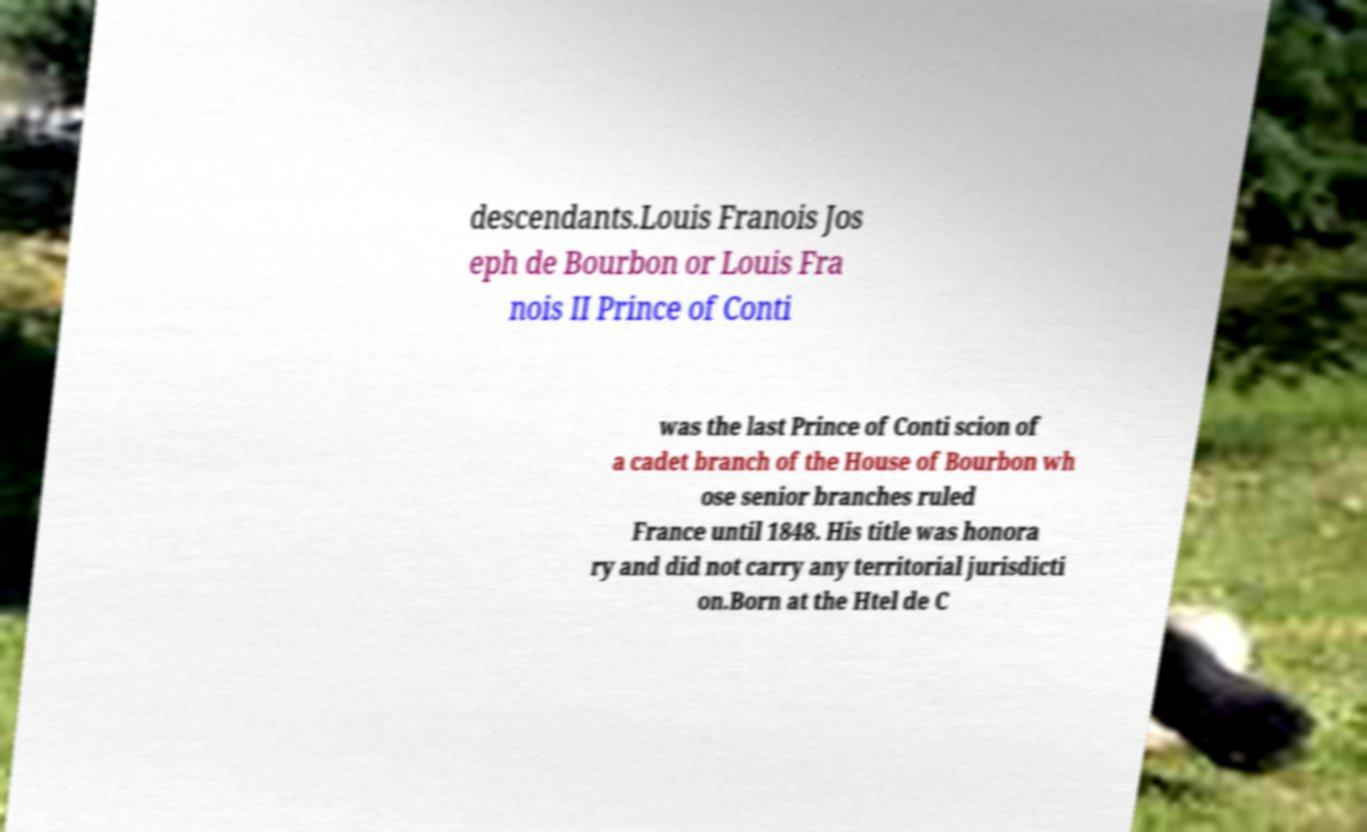Can you accurately transcribe the text from the provided image for me? descendants.Louis Franois Jos eph de Bourbon or Louis Fra nois II Prince of Conti was the last Prince of Conti scion of a cadet branch of the House of Bourbon wh ose senior branches ruled France until 1848. His title was honora ry and did not carry any territorial jurisdicti on.Born at the Htel de C 